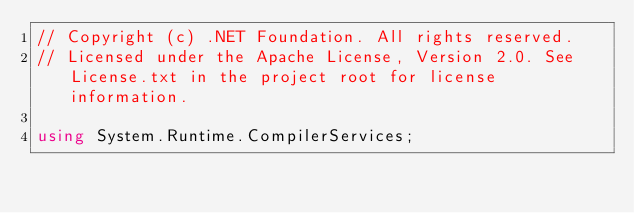<code> <loc_0><loc_0><loc_500><loc_500><_C#_>// Copyright (c) .NET Foundation. All rights reserved.
// Licensed under the Apache License, Version 2.0. See License.txt in the project root for license information.

using System.Runtime.CompilerServices;
</code> 